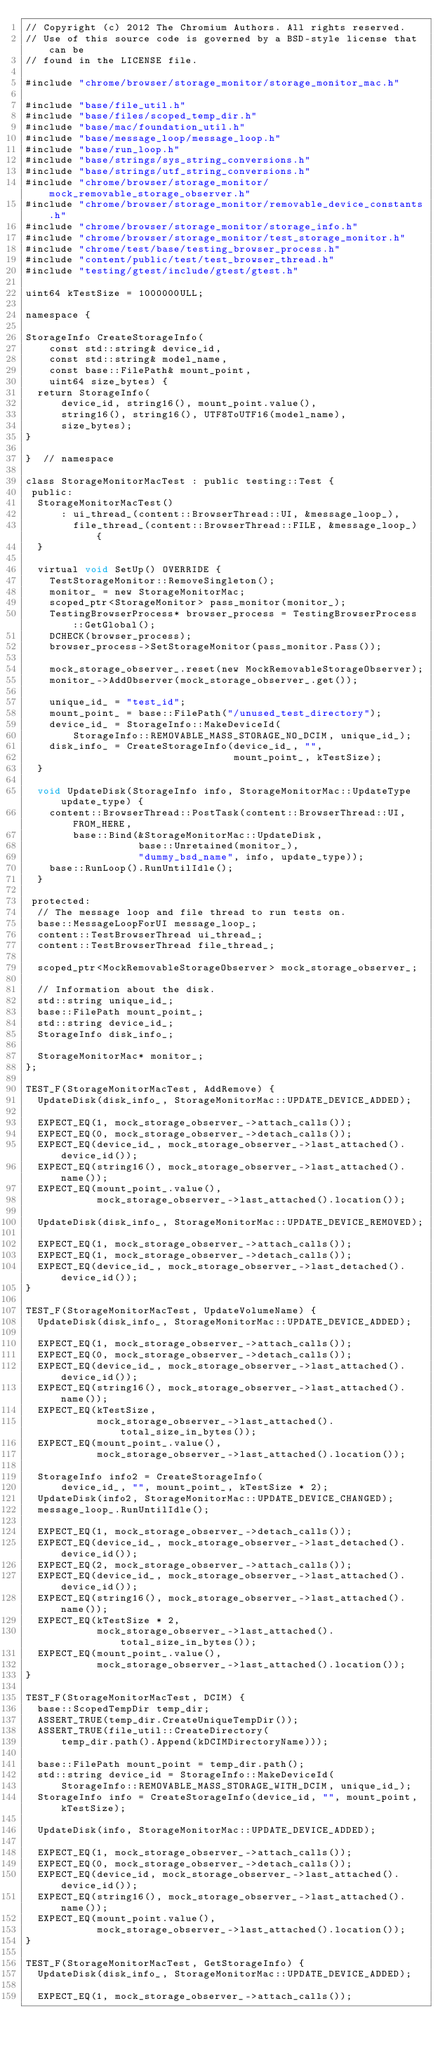Convert code to text. <code><loc_0><loc_0><loc_500><loc_500><_ObjectiveC_>// Copyright (c) 2012 The Chromium Authors. All rights reserved.
// Use of this source code is governed by a BSD-style license that can be
// found in the LICENSE file.

#include "chrome/browser/storage_monitor/storage_monitor_mac.h"

#include "base/file_util.h"
#include "base/files/scoped_temp_dir.h"
#include "base/mac/foundation_util.h"
#include "base/message_loop/message_loop.h"
#include "base/run_loop.h"
#include "base/strings/sys_string_conversions.h"
#include "base/strings/utf_string_conversions.h"
#include "chrome/browser/storage_monitor/mock_removable_storage_observer.h"
#include "chrome/browser/storage_monitor/removable_device_constants.h"
#include "chrome/browser/storage_monitor/storage_info.h"
#include "chrome/browser/storage_monitor/test_storage_monitor.h"
#include "chrome/test/base/testing_browser_process.h"
#include "content/public/test/test_browser_thread.h"
#include "testing/gtest/include/gtest/gtest.h"

uint64 kTestSize = 1000000ULL;

namespace {

StorageInfo CreateStorageInfo(
    const std::string& device_id,
    const std::string& model_name,
    const base::FilePath& mount_point,
    uint64 size_bytes) {
  return StorageInfo(
      device_id, string16(), mount_point.value(),
      string16(), string16(), UTF8ToUTF16(model_name),
      size_bytes);
}

}  // namespace

class StorageMonitorMacTest : public testing::Test {
 public:
  StorageMonitorMacTest()
      : ui_thread_(content::BrowserThread::UI, &message_loop_),
        file_thread_(content::BrowserThread::FILE, &message_loop_) {
  }

  virtual void SetUp() OVERRIDE {
    TestStorageMonitor::RemoveSingleton();
    monitor_ = new StorageMonitorMac;
    scoped_ptr<StorageMonitor> pass_monitor(monitor_);
    TestingBrowserProcess* browser_process = TestingBrowserProcess::GetGlobal();
    DCHECK(browser_process);
    browser_process->SetStorageMonitor(pass_monitor.Pass());

    mock_storage_observer_.reset(new MockRemovableStorageObserver);
    monitor_->AddObserver(mock_storage_observer_.get());

    unique_id_ = "test_id";
    mount_point_ = base::FilePath("/unused_test_directory");
    device_id_ = StorageInfo::MakeDeviceId(
        StorageInfo::REMOVABLE_MASS_STORAGE_NO_DCIM, unique_id_);
    disk_info_ = CreateStorageInfo(device_id_, "",
                                   mount_point_, kTestSize);
  }

  void UpdateDisk(StorageInfo info, StorageMonitorMac::UpdateType update_type) {
    content::BrowserThread::PostTask(content::BrowserThread::UI, FROM_HERE,
        base::Bind(&StorageMonitorMac::UpdateDisk,
                   base::Unretained(monitor_),
                   "dummy_bsd_name", info, update_type));
    base::RunLoop().RunUntilIdle();
  }

 protected:
  // The message loop and file thread to run tests on.
  base::MessageLoopForUI message_loop_;
  content::TestBrowserThread ui_thread_;
  content::TestBrowserThread file_thread_;

  scoped_ptr<MockRemovableStorageObserver> mock_storage_observer_;

  // Information about the disk.
  std::string unique_id_;
  base::FilePath mount_point_;
  std::string device_id_;
  StorageInfo disk_info_;

  StorageMonitorMac* monitor_;
};

TEST_F(StorageMonitorMacTest, AddRemove) {
  UpdateDisk(disk_info_, StorageMonitorMac::UPDATE_DEVICE_ADDED);

  EXPECT_EQ(1, mock_storage_observer_->attach_calls());
  EXPECT_EQ(0, mock_storage_observer_->detach_calls());
  EXPECT_EQ(device_id_, mock_storage_observer_->last_attached().device_id());
  EXPECT_EQ(string16(), mock_storage_observer_->last_attached().name());
  EXPECT_EQ(mount_point_.value(),
            mock_storage_observer_->last_attached().location());

  UpdateDisk(disk_info_, StorageMonitorMac::UPDATE_DEVICE_REMOVED);

  EXPECT_EQ(1, mock_storage_observer_->attach_calls());
  EXPECT_EQ(1, mock_storage_observer_->detach_calls());
  EXPECT_EQ(device_id_, mock_storage_observer_->last_detached().device_id());
}

TEST_F(StorageMonitorMacTest, UpdateVolumeName) {
  UpdateDisk(disk_info_, StorageMonitorMac::UPDATE_DEVICE_ADDED);

  EXPECT_EQ(1, mock_storage_observer_->attach_calls());
  EXPECT_EQ(0, mock_storage_observer_->detach_calls());
  EXPECT_EQ(device_id_, mock_storage_observer_->last_attached().device_id());
  EXPECT_EQ(string16(), mock_storage_observer_->last_attached().name());
  EXPECT_EQ(kTestSize,
            mock_storage_observer_->last_attached().total_size_in_bytes());
  EXPECT_EQ(mount_point_.value(),
            mock_storage_observer_->last_attached().location());

  StorageInfo info2 = CreateStorageInfo(
      device_id_, "", mount_point_, kTestSize * 2);
  UpdateDisk(info2, StorageMonitorMac::UPDATE_DEVICE_CHANGED);
  message_loop_.RunUntilIdle();

  EXPECT_EQ(1, mock_storage_observer_->detach_calls());
  EXPECT_EQ(device_id_, mock_storage_observer_->last_detached().device_id());
  EXPECT_EQ(2, mock_storage_observer_->attach_calls());
  EXPECT_EQ(device_id_, mock_storage_observer_->last_attached().device_id());
  EXPECT_EQ(string16(), mock_storage_observer_->last_attached().name());
  EXPECT_EQ(kTestSize * 2,
            mock_storage_observer_->last_attached().total_size_in_bytes());
  EXPECT_EQ(mount_point_.value(),
            mock_storage_observer_->last_attached().location());
}

TEST_F(StorageMonitorMacTest, DCIM) {
  base::ScopedTempDir temp_dir;
  ASSERT_TRUE(temp_dir.CreateUniqueTempDir());
  ASSERT_TRUE(file_util::CreateDirectory(
      temp_dir.path().Append(kDCIMDirectoryName)));

  base::FilePath mount_point = temp_dir.path();
  std::string device_id = StorageInfo::MakeDeviceId(
      StorageInfo::REMOVABLE_MASS_STORAGE_WITH_DCIM, unique_id_);
  StorageInfo info = CreateStorageInfo(device_id, "", mount_point, kTestSize);

  UpdateDisk(info, StorageMonitorMac::UPDATE_DEVICE_ADDED);

  EXPECT_EQ(1, mock_storage_observer_->attach_calls());
  EXPECT_EQ(0, mock_storage_observer_->detach_calls());
  EXPECT_EQ(device_id, mock_storage_observer_->last_attached().device_id());
  EXPECT_EQ(string16(), mock_storage_observer_->last_attached().name());
  EXPECT_EQ(mount_point.value(),
            mock_storage_observer_->last_attached().location());
}

TEST_F(StorageMonitorMacTest, GetStorageInfo) {
  UpdateDisk(disk_info_, StorageMonitorMac::UPDATE_DEVICE_ADDED);

  EXPECT_EQ(1, mock_storage_observer_->attach_calls());</code> 